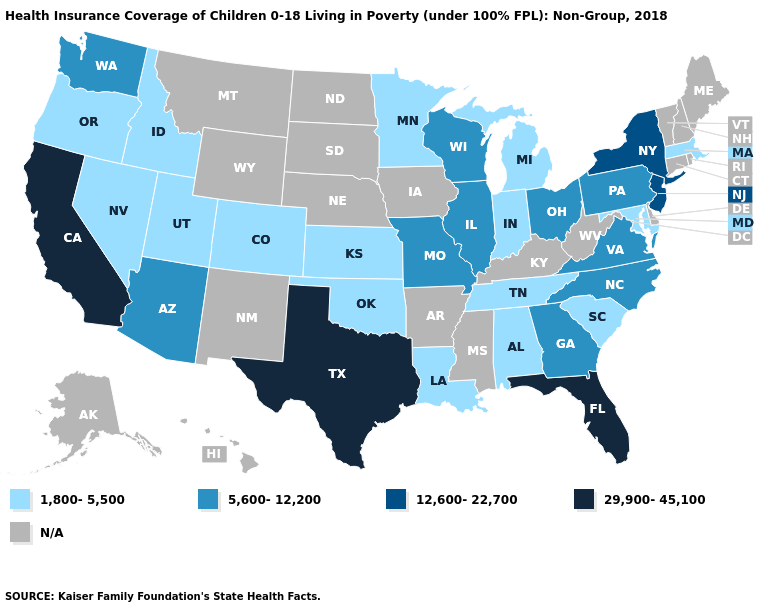What is the lowest value in the USA?
Give a very brief answer. 1,800-5,500. Name the states that have a value in the range 1,800-5,500?
Write a very short answer. Alabama, Colorado, Idaho, Indiana, Kansas, Louisiana, Maryland, Massachusetts, Michigan, Minnesota, Nevada, Oklahoma, Oregon, South Carolina, Tennessee, Utah. What is the lowest value in states that border Nevada?
Quick response, please. 1,800-5,500. What is the value of Michigan?
Keep it brief. 1,800-5,500. What is the lowest value in the USA?
Short answer required. 1,800-5,500. Does Massachusetts have the highest value in the USA?
Short answer required. No. Does the map have missing data?
Keep it brief. Yes. Which states have the lowest value in the West?
Concise answer only. Colorado, Idaho, Nevada, Oregon, Utah. Does the map have missing data?
Write a very short answer. Yes. Name the states that have a value in the range 29,900-45,100?
Quick response, please. California, Florida, Texas. What is the lowest value in the West?
Keep it brief. 1,800-5,500. What is the value of Wisconsin?
Short answer required. 5,600-12,200. What is the lowest value in the South?
Be succinct. 1,800-5,500. Name the states that have a value in the range 1,800-5,500?
Give a very brief answer. Alabama, Colorado, Idaho, Indiana, Kansas, Louisiana, Maryland, Massachusetts, Michigan, Minnesota, Nevada, Oklahoma, Oregon, South Carolina, Tennessee, Utah. 